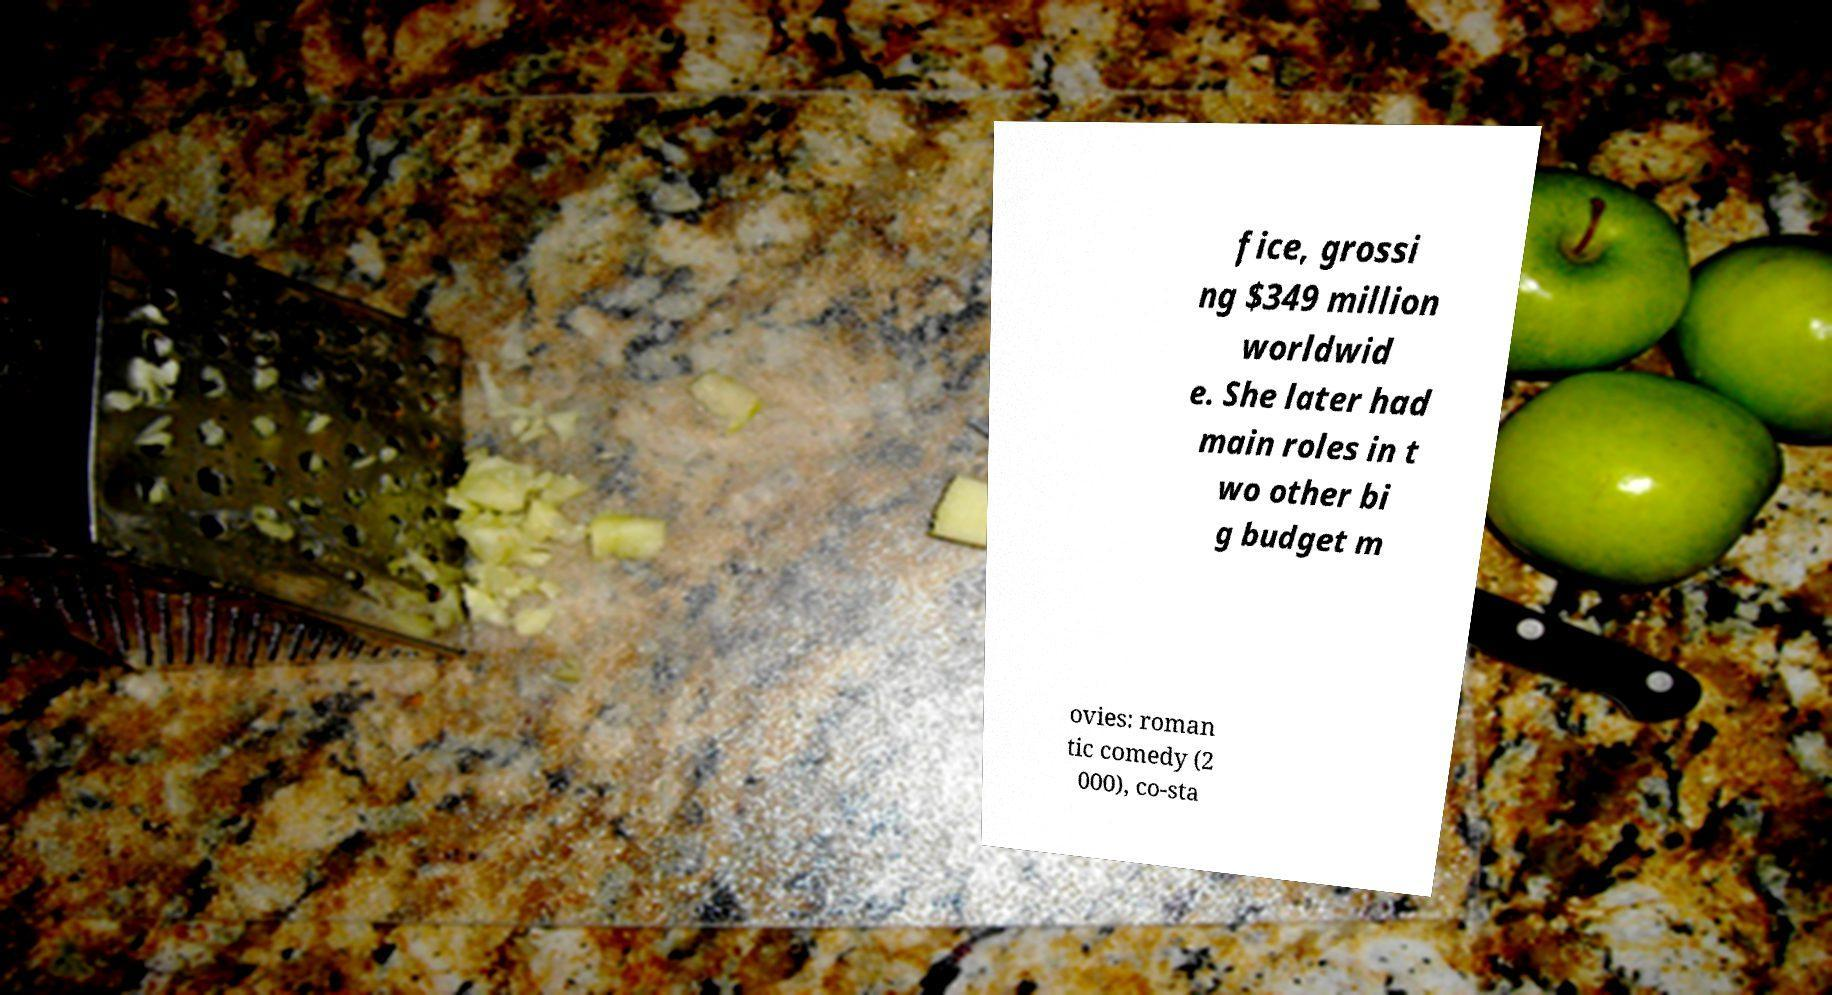Can you read and provide the text displayed in the image?This photo seems to have some interesting text. Can you extract and type it out for me? fice, grossi ng $349 million worldwid e. She later had main roles in t wo other bi g budget m ovies: roman tic comedy (2 000), co-sta 